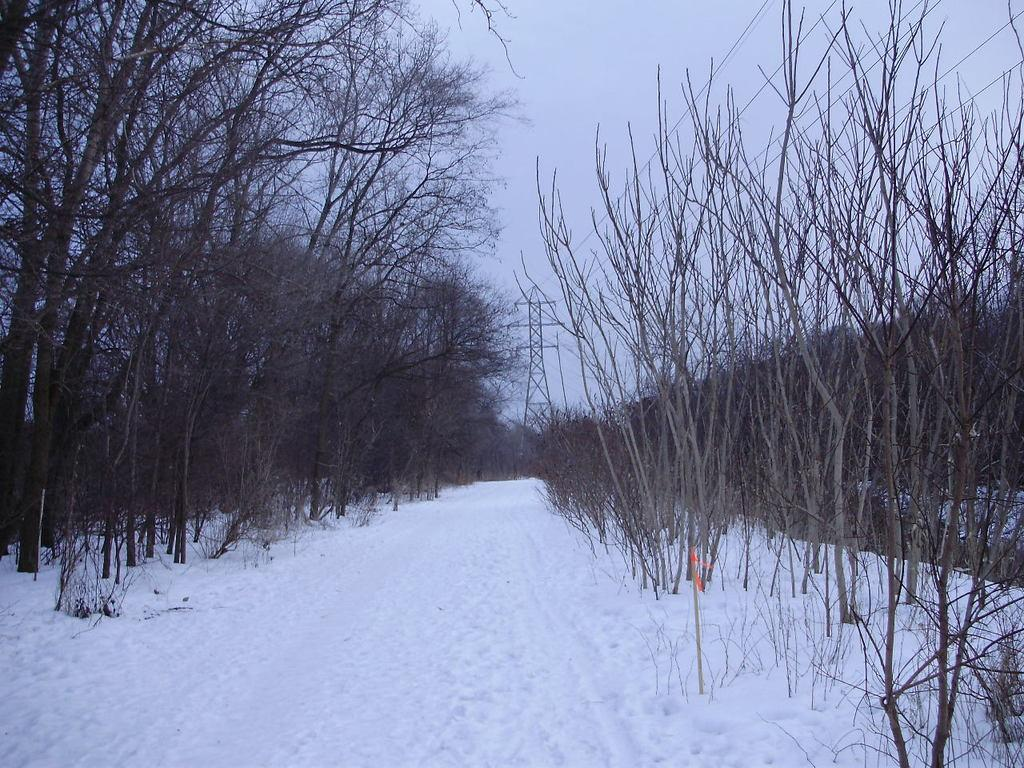What type of vegetation can be seen in the image? There are trees in the image. What part of the natural environment is visible in the image? The sky is visible in the image. What man-made structure can be seen in the image? There is a tower visible in the image. What type of infrastructure is present in the image? There is a power line cable in the image. How many snails can be seen crawling on the trees in the image? There are no snails visible in the image; it only features trees and a tower. What time of day is depicted in the image? The time of day cannot be determined from the image, as there are no specific indicators of time. 